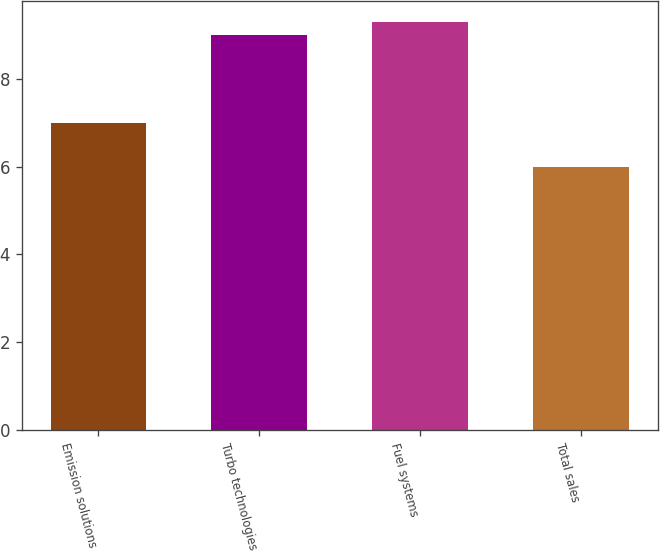Convert chart. <chart><loc_0><loc_0><loc_500><loc_500><bar_chart><fcel>Emission solutions<fcel>Turbo technologies<fcel>Fuel systems<fcel>Total sales<nl><fcel>7<fcel>9<fcel>9.3<fcel>6<nl></chart> 